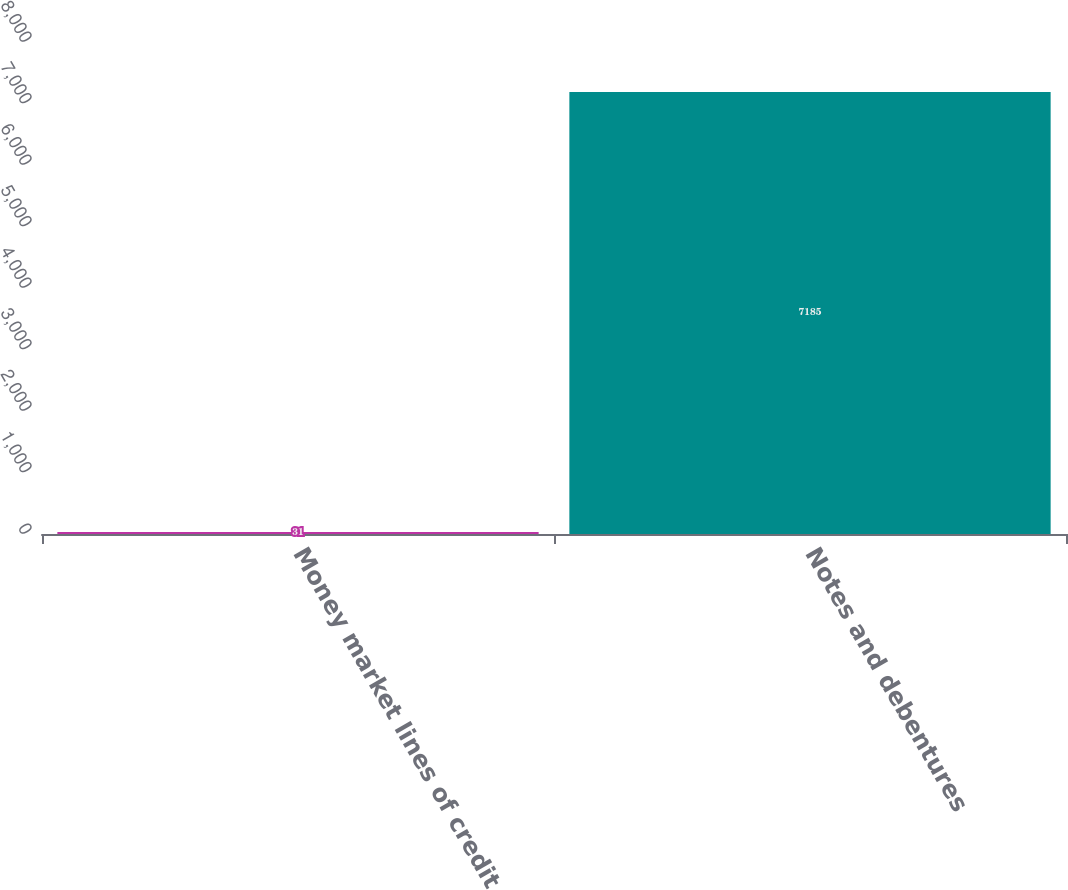Convert chart to OTSL. <chart><loc_0><loc_0><loc_500><loc_500><bar_chart><fcel>Money market lines of credit<fcel>Notes and debentures<nl><fcel>31<fcel>7185<nl></chart> 